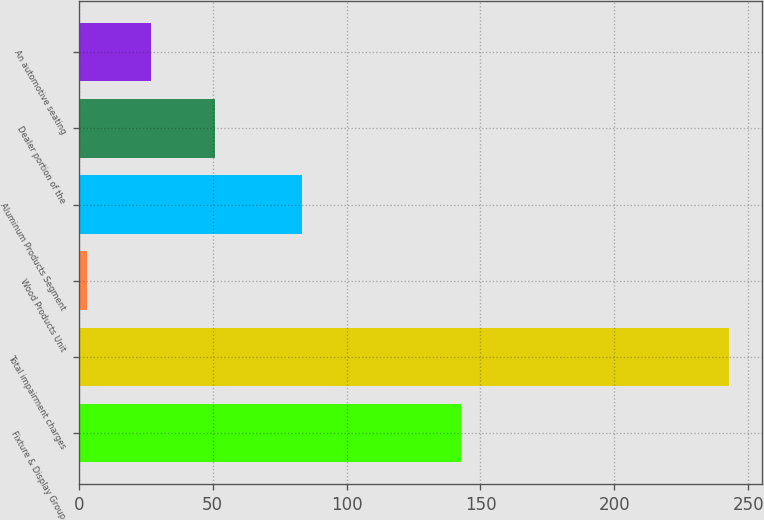<chart> <loc_0><loc_0><loc_500><loc_500><bar_chart><fcel>Fixture & Display Group<fcel>Total impairment charges<fcel>Wood Products Unit<fcel>Aluminum Products Segment<fcel>Dealer portion of the<fcel>An automotive seating<nl><fcel>142.6<fcel>243<fcel>2.9<fcel>83.3<fcel>50.92<fcel>26.91<nl></chart> 